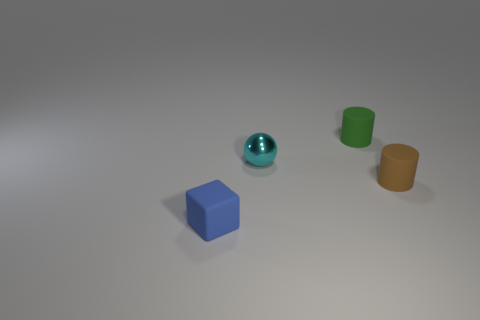Add 2 brown rubber cylinders. How many objects exist? 6 Subtract all spheres. How many objects are left? 3 Subtract 0 purple blocks. How many objects are left? 4 Subtract all tiny green rubber cylinders. Subtract all green cylinders. How many objects are left? 2 Add 3 small green things. How many small green things are left? 4 Add 3 small blue cubes. How many small blue cubes exist? 4 